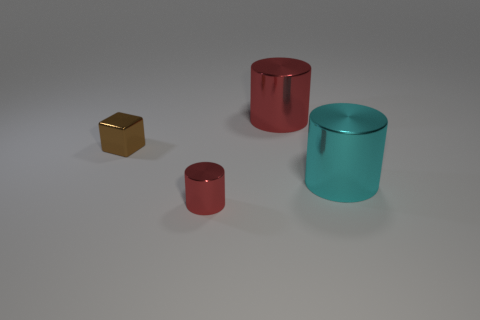Add 4 green cubes. How many objects exist? 8 Subtract all cubes. How many objects are left? 3 Add 3 small metallic objects. How many small metallic objects are left? 5 Add 2 green cylinders. How many green cylinders exist? 2 Subtract 0 blue balls. How many objects are left? 4 Subtract all tiny yellow rubber cubes. Subtract all brown metal objects. How many objects are left? 3 